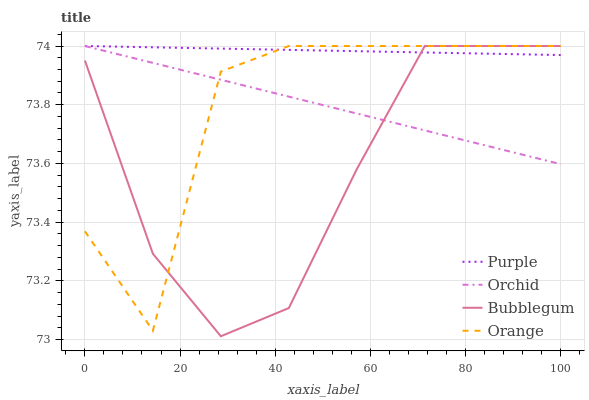Does Bubblegum have the minimum area under the curve?
Answer yes or no. Yes. Does Purple have the maximum area under the curve?
Answer yes or no. Yes. Does Orange have the minimum area under the curve?
Answer yes or no. No. Does Orange have the maximum area under the curve?
Answer yes or no. No. Is Orchid the smoothest?
Answer yes or no. Yes. Is Orange the roughest?
Answer yes or no. Yes. Is Bubblegum the smoothest?
Answer yes or no. No. Is Bubblegum the roughest?
Answer yes or no. No. Does Bubblegum have the lowest value?
Answer yes or no. Yes. Does Orange have the lowest value?
Answer yes or no. No. Does Orchid have the highest value?
Answer yes or no. Yes. Does Orchid intersect Orange?
Answer yes or no. Yes. Is Orchid less than Orange?
Answer yes or no. No. Is Orchid greater than Orange?
Answer yes or no. No. 